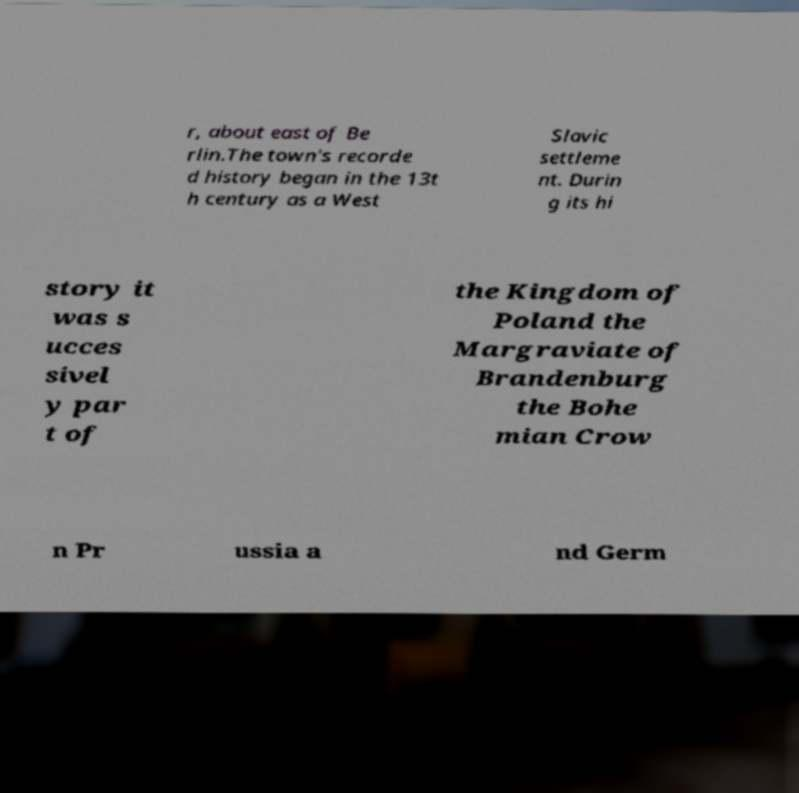I need the written content from this picture converted into text. Can you do that? r, about east of Be rlin.The town's recorde d history began in the 13t h century as a West Slavic settleme nt. Durin g its hi story it was s ucces sivel y par t of the Kingdom of Poland the Margraviate of Brandenburg the Bohe mian Crow n Pr ussia a nd Germ 